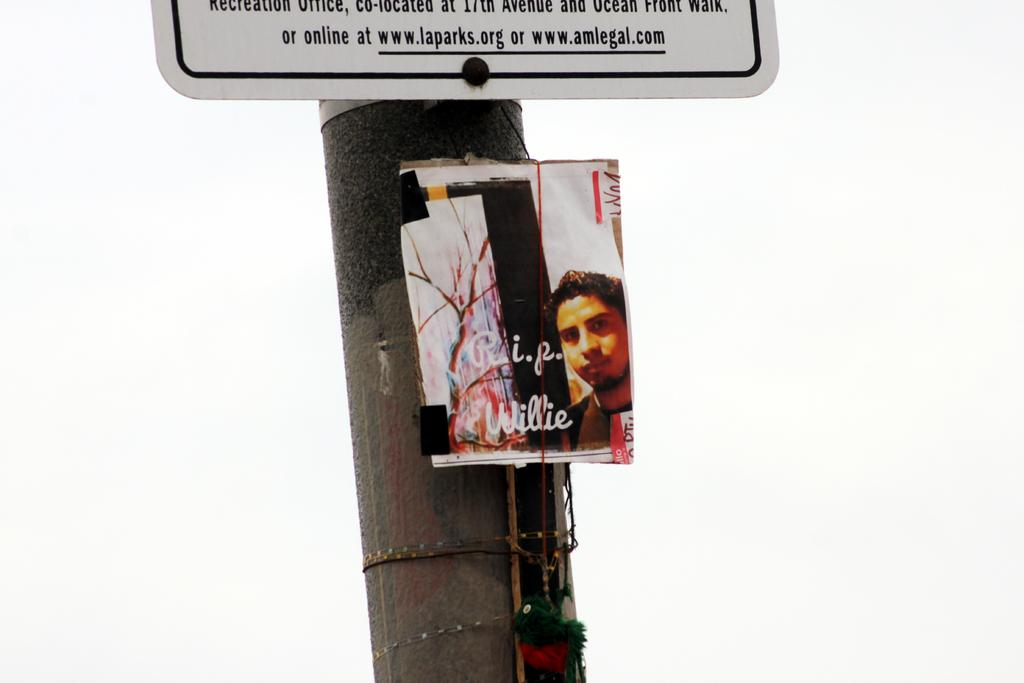What is attached to the pole in the image? There is a board with text on it attached to the pole in the image. What else is present beneath the board? There is a poster of a person beneath the board. What can be found on the poster? There is text on the poster. What can be seen in the background of the image? The sky is visible in the background of the image. Can you see any owls sitting on the pole in the image? There are no owls present in the image. How many friends are visible in the image? There is no reference to friends in the image. 